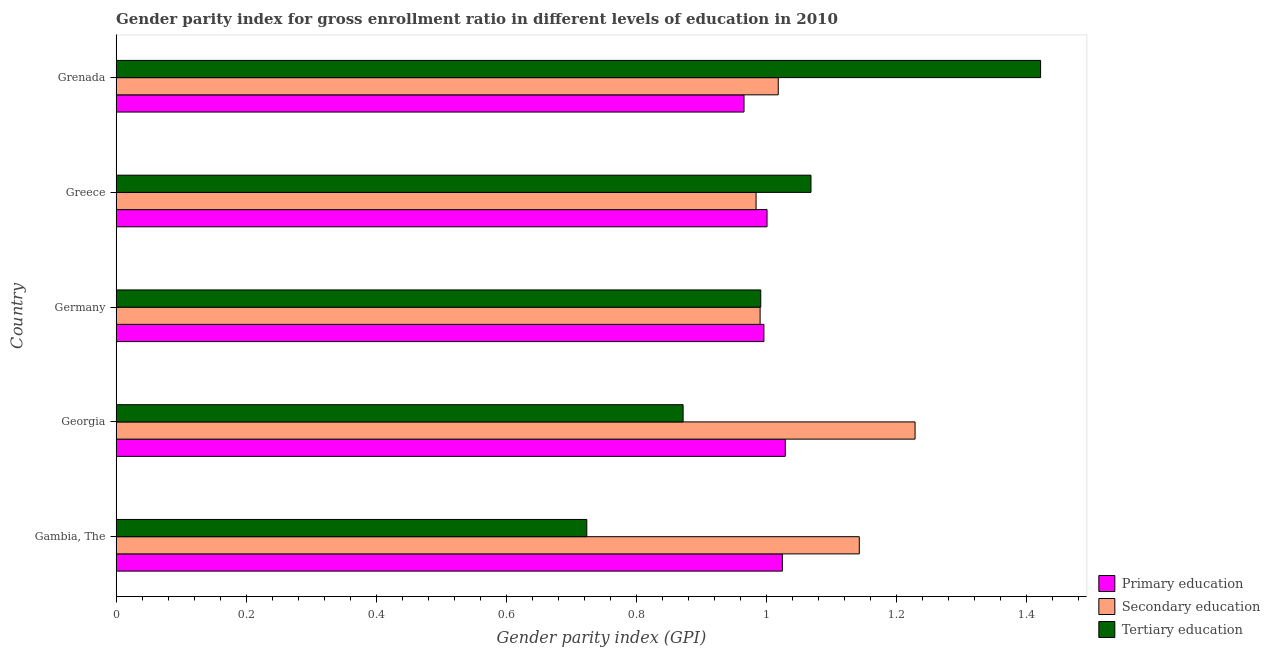How many groups of bars are there?
Offer a very short reply. 5. Are the number of bars per tick equal to the number of legend labels?
Ensure brevity in your answer.  Yes. Are the number of bars on each tick of the Y-axis equal?
Provide a succinct answer. Yes. How many bars are there on the 1st tick from the bottom?
Provide a short and direct response. 3. What is the label of the 4th group of bars from the top?
Ensure brevity in your answer.  Georgia. In how many cases, is the number of bars for a given country not equal to the number of legend labels?
Your answer should be very brief. 0. What is the gender parity index in secondary education in Germany?
Provide a short and direct response. 0.99. Across all countries, what is the maximum gender parity index in tertiary education?
Your response must be concise. 1.42. Across all countries, what is the minimum gender parity index in tertiary education?
Ensure brevity in your answer.  0.72. In which country was the gender parity index in tertiary education maximum?
Your answer should be very brief. Grenada. In which country was the gender parity index in tertiary education minimum?
Your response must be concise. Gambia, The. What is the total gender parity index in tertiary education in the graph?
Your answer should be compact. 5.08. What is the difference between the gender parity index in tertiary education in Georgia and that in Greece?
Your answer should be compact. -0.2. What is the difference between the gender parity index in tertiary education in Grenada and the gender parity index in secondary education in Greece?
Offer a terse response. 0.44. What is the average gender parity index in secondary education per country?
Offer a very short reply. 1.07. What is the difference between the gender parity index in secondary education and gender parity index in tertiary education in Georgia?
Provide a short and direct response. 0.36. In how many countries, is the gender parity index in primary education greater than 0.04 ?
Your response must be concise. 5. What is the ratio of the gender parity index in secondary education in Germany to that in Grenada?
Ensure brevity in your answer.  0.97. Is the gender parity index in primary education in Georgia less than that in Germany?
Give a very brief answer. No. Is the difference between the gender parity index in secondary education in Georgia and Greece greater than the difference between the gender parity index in tertiary education in Georgia and Greece?
Give a very brief answer. Yes. What is the difference between the highest and the second highest gender parity index in primary education?
Your answer should be compact. 0. What is the difference between the highest and the lowest gender parity index in tertiary education?
Keep it short and to the point. 0.7. In how many countries, is the gender parity index in tertiary education greater than the average gender parity index in tertiary education taken over all countries?
Your response must be concise. 2. Is the sum of the gender parity index in tertiary education in Georgia and Germany greater than the maximum gender parity index in secondary education across all countries?
Give a very brief answer. Yes. What does the 2nd bar from the top in Grenada represents?
Provide a succinct answer. Secondary education. What does the 3rd bar from the bottom in Germany represents?
Give a very brief answer. Tertiary education. Is it the case that in every country, the sum of the gender parity index in primary education and gender parity index in secondary education is greater than the gender parity index in tertiary education?
Your answer should be very brief. Yes. How many bars are there?
Give a very brief answer. 15. How many countries are there in the graph?
Your response must be concise. 5. Does the graph contain any zero values?
Ensure brevity in your answer.  No. How many legend labels are there?
Make the answer very short. 3. How are the legend labels stacked?
Make the answer very short. Vertical. What is the title of the graph?
Your response must be concise. Gender parity index for gross enrollment ratio in different levels of education in 2010. Does "Tertiary education" appear as one of the legend labels in the graph?
Your answer should be compact. Yes. What is the label or title of the X-axis?
Provide a short and direct response. Gender parity index (GPI). What is the label or title of the Y-axis?
Provide a succinct answer. Country. What is the Gender parity index (GPI) in Primary education in Gambia, The?
Provide a succinct answer. 1.02. What is the Gender parity index (GPI) of Secondary education in Gambia, The?
Offer a very short reply. 1.14. What is the Gender parity index (GPI) in Tertiary education in Gambia, The?
Make the answer very short. 0.72. What is the Gender parity index (GPI) in Primary education in Georgia?
Ensure brevity in your answer.  1.03. What is the Gender parity index (GPI) in Secondary education in Georgia?
Make the answer very short. 1.23. What is the Gender parity index (GPI) of Tertiary education in Georgia?
Your answer should be very brief. 0.87. What is the Gender parity index (GPI) of Primary education in Germany?
Offer a very short reply. 1. What is the Gender parity index (GPI) in Secondary education in Germany?
Your answer should be very brief. 0.99. What is the Gender parity index (GPI) in Tertiary education in Germany?
Give a very brief answer. 0.99. What is the Gender parity index (GPI) in Primary education in Greece?
Give a very brief answer. 1. What is the Gender parity index (GPI) in Secondary education in Greece?
Provide a short and direct response. 0.98. What is the Gender parity index (GPI) in Tertiary education in Greece?
Give a very brief answer. 1.07. What is the Gender parity index (GPI) in Primary education in Grenada?
Give a very brief answer. 0.97. What is the Gender parity index (GPI) in Secondary education in Grenada?
Keep it short and to the point. 1.02. What is the Gender parity index (GPI) of Tertiary education in Grenada?
Offer a terse response. 1.42. Across all countries, what is the maximum Gender parity index (GPI) in Primary education?
Your answer should be compact. 1.03. Across all countries, what is the maximum Gender parity index (GPI) in Secondary education?
Offer a terse response. 1.23. Across all countries, what is the maximum Gender parity index (GPI) of Tertiary education?
Ensure brevity in your answer.  1.42. Across all countries, what is the minimum Gender parity index (GPI) of Primary education?
Offer a terse response. 0.97. Across all countries, what is the minimum Gender parity index (GPI) of Secondary education?
Make the answer very short. 0.98. Across all countries, what is the minimum Gender parity index (GPI) in Tertiary education?
Offer a very short reply. 0.72. What is the total Gender parity index (GPI) of Primary education in the graph?
Your answer should be compact. 5.02. What is the total Gender parity index (GPI) of Secondary education in the graph?
Keep it short and to the point. 5.37. What is the total Gender parity index (GPI) of Tertiary education in the graph?
Offer a very short reply. 5.08. What is the difference between the Gender parity index (GPI) of Primary education in Gambia, The and that in Georgia?
Offer a terse response. -0. What is the difference between the Gender parity index (GPI) in Secondary education in Gambia, The and that in Georgia?
Offer a terse response. -0.09. What is the difference between the Gender parity index (GPI) of Tertiary education in Gambia, The and that in Georgia?
Provide a short and direct response. -0.15. What is the difference between the Gender parity index (GPI) in Primary education in Gambia, The and that in Germany?
Your answer should be very brief. 0.03. What is the difference between the Gender parity index (GPI) in Secondary education in Gambia, The and that in Germany?
Your response must be concise. 0.15. What is the difference between the Gender parity index (GPI) in Tertiary education in Gambia, The and that in Germany?
Give a very brief answer. -0.27. What is the difference between the Gender parity index (GPI) of Primary education in Gambia, The and that in Greece?
Provide a succinct answer. 0.02. What is the difference between the Gender parity index (GPI) of Secondary education in Gambia, The and that in Greece?
Offer a very short reply. 0.16. What is the difference between the Gender parity index (GPI) of Tertiary education in Gambia, The and that in Greece?
Your response must be concise. -0.34. What is the difference between the Gender parity index (GPI) in Primary education in Gambia, The and that in Grenada?
Make the answer very short. 0.06. What is the difference between the Gender parity index (GPI) in Secondary education in Gambia, The and that in Grenada?
Your response must be concise. 0.12. What is the difference between the Gender parity index (GPI) in Tertiary education in Gambia, The and that in Grenada?
Your response must be concise. -0.7. What is the difference between the Gender parity index (GPI) of Primary education in Georgia and that in Germany?
Your answer should be compact. 0.03. What is the difference between the Gender parity index (GPI) in Secondary education in Georgia and that in Germany?
Keep it short and to the point. 0.24. What is the difference between the Gender parity index (GPI) in Tertiary education in Georgia and that in Germany?
Provide a succinct answer. -0.12. What is the difference between the Gender parity index (GPI) in Primary education in Georgia and that in Greece?
Keep it short and to the point. 0.03. What is the difference between the Gender parity index (GPI) in Secondary education in Georgia and that in Greece?
Ensure brevity in your answer.  0.24. What is the difference between the Gender parity index (GPI) of Tertiary education in Georgia and that in Greece?
Make the answer very short. -0.2. What is the difference between the Gender parity index (GPI) in Primary education in Georgia and that in Grenada?
Make the answer very short. 0.06. What is the difference between the Gender parity index (GPI) in Secondary education in Georgia and that in Grenada?
Your answer should be compact. 0.21. What is the difference between the Gender parity index (GPI) in Tertiary education in Georgia and that in Grenada?
Offer a very short reply. -0.55. What is the difference between the Gender parity index (GPI) in Primary education in Germany and that in Greece?
Offer a very short reply. -0. What is the difference between the Gender parity index (GPI) in Secondary education in Germany and that in Greece?
Provide a succinct answer. 0.01. What is the difference between the Gender parity index (GPI) of Tertiary education in Germany and that in Greece?
Your answer should be compact. -0.08. What is the difference between the Gender parity index (GPI) of Primary education in Germany and that in Grenada?
Ensure brevity in your answer.  0.03. What is the difference between the Gender parity index (GPI) of Secondary education in Germany and that in Grenada?
Provide a short and direct response. -0.03. What is the difference between the Gender parity index (GPI) in Tertiary education in Germany and that in Grenada?
Your answer should be very brief. -0.43. What is the difference between the Gender parity index (GPI) in Primary education in Greece and that in Grenada?
Give a very brief answer. 0.04. What is the difference between the Gender parity index (GPI) of Secondary education in Greece and that in Grenada?
Offer a terse response. -0.03. What is the difference between the Gender parity index (GPI) in Tertiary education in Greece and that in Grenada?
Offer a terse response. -0.35. What is the difference between the Gender parity index (GPI) of Primary education in Gambia, The and the Gender parity index (GPI) of Secondary education in Georgia?
Provide a succinct answer. -0.2. What is the difference between the Gender parity index (GPI) of Primary education in Gambia, The and the Gender parity index (GPI) of Tertiary education in Georgia?
Provide a succinct answer. 0.15. What is the difference between the Gender parity index (GPI) in Secondary education in Gambia, The and the Gender parity index (GPI) in Tertiary education in Georgia?
Your answer should be compact. 0.27. What is the difference between the Gender parity index (GPI) in Primary education in Gambia, The and the Gender parity index (GPI) in Secondary education in Germany?
Keep it short and to the point. 0.03. What is the difference between the Gender parity index (GPI) in Primary education in Gambia, The and the Gender parity index (GPI) in Tertiary education in Germany?
Keep it short and to the point. 0.03. What is the difference between the Gender parity index (GPI) of Secondary education in Gambia, The and the Gender parity index (GPI) of Tertiary education in Germany?
Offer a very short reply. 0.15. What is the difference between the Gender parity index (GPI) in Primary education in Gambia, The and the Gender parity index (GPI) in Secondary education in Greece?
Make the answer very short. 0.04. What is the difference between the Gender parity index (GPI) of Primary education in Gambia, The and the Gender parity index (GPI) of Tertiary education in Greece?
Provide a short and direct response. -0.04. What is the difference between the Gender parity index (GPI) of Secondary education in Gambia, The and the Gender parity index (GPI) of Tertiary education in Greece?
Provide a succinct answer. 0.07. What is the difference between the Gender parity index (GPI) in Primary education in Gambia, The and the Gender parity index (GPI) in Secondary education in Grenada?
Your answer should be very brief. 0.01. What is the difference between the Gender parity index (GPI) of Primary education in Gambia, The and the Gender parity index (GPI) of Tertiary education in Grenada?
Your answer should be very brief. -0.4. What is the difference between the Gender parity index (GPI) in Secondary education in Gambia, The and the Gender parity index (GPI) in Tertiary education in Grenada?
Offer a very short reply. -0.28. What is the difference between the Gender parity index (GPI) in Primary education in Georgia and the Gender parity index (GPI) in Secondary education in Germany?
Offer a terse response. 0.04. What is the difference between the Gender parity index (GPI) in Primary education in Georgia and the Gender parity index (GPI) in Tertiary education in Germany?
Provide a short and direct response. 0.04. What is the difference between the Gender parity index (GPI) in Secondary education in Georgia and the Gender parity index (GPI) in Tertiary education in Germany?
Provide a succinct answer. 0.24. What is the difference between the Gender parity index (GPI) of Primary education in Georgia and the Gender parity index (GPI) of Secondary education in Greece?
Give a very brief answer. 0.04. What is the difference between the Gender parity index (GPI) of Primary education in Georgia and the Gender parity index (GPI) of Tertiary education in Greece?
Provide a short and direct response. -0.04. What is the difference between the Gender parity index (GPI) in Secondary education in Georgia and the Gender parity index (GPI) in Tertiary education in Greece?
Offer a very short reply. 0.16. What is the difference between the Gender parity index (GPI) in Primary education in Georgia and the Gender parity index (GPI) in Secondary education in Grenada?
Give a very brief answer. 0.01. What is the difference between the Gender parity index (GPI) in Primary education in Georgia and the Gender parity index (GPI) in Tertiary education in Grenada?
Keep it short and to the point. -0.39. What is the difference between the Gender parity index (GPI) in Secondary education in Georgia and the Gender parity index (GPI) in Tertiary education in Grenada?
Your response must be concise. -0.19. What is the difference between the Gender parity index (GPI) of Primary education in Germany and the Gender parity index (GPI) of Secondary education in Greece?
Provide a short and direct response. 0.01. What is the difference between the Gender parity index (GPI) in Primary education in Germany and the Gender parity index (GPI) in Tertiary education in Greece?
Offer a very short reply. -0.07. What is the difference between the Gender parity index (GPI) in Secondary education in Germany and the Gender parity index (GPI) in Tertiary education in Greece?
Make the answer very short. -0.08. What is the difference between the Gender parity index (GPI) of Primary education in Germany and the Gender parity index (GPI) of Secondary education in Grenada?
Provide a short and direct response. -0.02. What is the difference between the Gender parity index (GPI) of Primary education in Germany and the Gender parity index (GPI) of Tertiary education in Grenada?
Your answer should be compact. -0.43. What is the difference between the Gender parity index (GPI) in Secondary education in Germany and the Gender parity index (GPI) in Tertiary education in Grenada?
Provide a succinct answer. -0.43. What is the difference between the Gender parity index (GPI) of Primary education in Greece and the Gender parity index (GPI) of Secondary education in Grenada?
Ensure brevity in your answer.  -0.02. What is the difference between the Gender parity index (GPI) in Primary education in Greece and the Gender parity index (GPI) in Tertiary education in Grenada?
Keep it short and to the point. -0.42. What is the difference between the Gender parity index (GPI) in Secondary education in Greece and the Gender parity index (GPI) in Tertiary education in Grenada?
Ensure brevity in your answer.  -0.44. What is the average Gender parity index (GPI) of Secondary education per country?
Your response must be concise. 1.07. What is the average Gender parity index (GPI) of Tertiary education per country?
Your response must be concise. 1.02. What is the difference between the Gender parity index (GPI) in Primary education and Gender parity index (GPI) in Secondary education in Gambia, The?
Provide a short and direct response. -0.12. What is the difference between the Gender parity index (GPI) of Primary education and Gender parity index (GPI) of Tertiary education in Gambia, The?
Provide a succinct answer. 0.3. What is the difference between the Gender parity index (GPI) in Secondary education and Gender parity index (GPI) in Tertiary education in Gambia, The?
Keep it short and to the point. 0.42. What is the difference between the Gender parity index (GPI) of Primary education and Gender parity index (GPI) of Secondary education in Georgia?
Ensure brevity in your answer.  -0.2. What is the difference between the Gender parity index (GPI) of Primary education and Gender parity index (GPI) of Tertiary education in Georgia?
Your response must be concise. 0.16. What is the difference between the Gender parity index (GPI) in Secondary education and Gender parity index (GPI) in Tertiary education in Georgia?
Provide a succinct answer. 0.36. What is the difference between the Gender parity index (GPI) in Primary education and Gender parity index (GPI) in Secondary education in Germany?
Provide a succinct answer. 0.01. What is the difference between the Gender parity index (GPI) of Primary education and Gender parity index (GPI) of Tertiary education in Germany?
Provide a short and direct response. 0. What is the difference between the Gender parity index (GPI) in Secondary education and Gender parity index (GPI) in Tertiary education in Germany?
Make the answer very short. -0. What is the difference between the Gender parity index (GPI) in Primary education and Gender parity index (GPI) in Secondary education in Greece?
Your answer should be very brief. 0.02. What is the difference between the Gender parity index (GPI) in Primary education and Gender parity index (GPI) in Tertiary education in Greece?
Provide a short and direct response. -0.07. What is the difference between the Gender parity index (GPI) in Secondary education and Gender parity index (GPI) in Tertiary education in Greece?
Provide a short and direct response. -0.08. What is the difference between the Gender parity index (GPI) in Primary education and Gender parity index (GPI) in Secondary education in Grenada?
Your answer should be compact. -0.05. What is the difference between the Gender parity index (GPI) of Primary education and Gender parity index (GPI) of Tertiary education in Grenada?
Provide a short and direct response. -0.46. What is the difference between the Gender parity index (GPI) in Secondary education and Gender parity index (GPI) in Tertiary education in Grenada?
Keep it short and to the point. -0.4. What is the ratio of the Gender parity index (GPI) of Primary education in Gambia, The to that in Georgia?
Ensure brevity in your answer.  1. What is the ratio of the Gender parity index (GPI) in Secondary education in Gambia, The to that in Georgia?
Offer a terse response. 0.93. What is the ratio of the Gender parity index (GPI) in Tertiary education in Gambia, The to that in Georgia?
Your answer should be compact. 0.83. What is the ratio of the Gender parity index (GPI) in Primary education in Gambia, The to that in Germany?
Keep it short and to the point. 1.03. What is the ratio of the Gender parity index (GPI) of Secondary education in Gambia, The to that in Germany?
Provide a succinct answer. 1.15. What is the ratio of the Gender parity index (GPI) in Tertiary education in Gambia, The to that in Germany?
Ensure brevity in your answer.  0.73. What is the ratio of the Gender parity index (GPI) of Primary education in Gambia, The to that in Greece?
Your answer should be very brief. 1.02. What is the ratio of the Gender parity index (GPI) in Secondary education in Gambia, The to that in Greece?
Your answer should be compact. 1.16. What is the ratio of the Gender parity index (GPI) of Tertiary education in Gambia, The to that in Greece?
Keep it short and to the point. 0.68. What is the ratio of the Gender parity index (GPI) of Primary education in Gambia, The to that in Grenada?
Give a very brief answer. 1.06. What is the ratio of the Gender parity index (GPI) of Secondary education in Gambia, The to that in Grenada?
Ensure brevity in your answer.  1.12. What is the ratio of the Gender parity index (GPI) of Tertiary education in Gambia, The to that in Grenada?
Make the answer very short. 0.51. What is the ratio of the Gender parity index (GPI) of Primary education in Georgia to that in Germany?
Provide a short and direct response. 1.03. What is the ratio of the Gender parity index (GPI) of Secondary education in Georgia to that in Germany?
Ensure brevity in your answer.  1.24. What is the ratio of the Gender parity index (GPI) in Tertiary education in Georgia to that in Germany?
Make the answer very short. 0.88. What is the ratio of the Gender parity index (GPI) in Primary education in Georgia to that in Greece?
Your answer should be very brief. 1.03. What is the ratio of the Gender parity index (GPI) in Secondary education in Georgia to that in Greece?
Ensure brevity in your answer.  1.25. What is the ratio of the Gender parity index (GPI) of Tertiary education in Georgia to that in Greece?
Provide a short and direct response. 0.82. What is the ratio of the Gender parity index (GPI) in Primary education in Georgia to that in Grenada?
Offer a terse response. 1.07. What is the ratio of the Gender parity index (GPI) in Secondary education in Georgia to that in Grenada?
Give a very brief answer. 1.21. What is the ratio of the Gender parity index (GPI) in Tertiary education in Georgia to that in Grenada?
Your response must be concise. 0.61. What is the ratio of the Gender parity index (GPI) of Primary education in Germany to that in Greece?
Provide a short and direct response. 1. What is the ratio of the Gender parity index (GPI) in Secondary education in Germany to that in Greece?
Your answer should be compact. 1.01. What is the ratio of the Gender parity index (GPI) in Tertiary education in Germany to that in Greece?
Provide a succinct answer. 0.93. What is the ratio of the Gender parity index (GPI) of Primary education in Germany to that in Grenada?
Offer a terse response. 1.03. What is the ratio of the Gender parity index (GPI) in Secondary education in Germany to that in Grenada?
Offer a terse response. 0.97. What is the ratio of the Gender parity index (GPI) in Tertiary education in Germany to that in Grenada?
Your answer should be compact. 0.7. What is the ratio of the Gender parity index (GPI) in Primary education in Greece to that in Grenada?
Provide a succinct answer. 1.04. What is the ratio of the Gender parity index (GPI) of Secondary education in Greece to that in Grenada?
Keep it short and to the point. 0.97. What is the ratio of the Gender parity index (GPI) in Tertiary education in Greece to that in Grenada?
Make the answer very short. 0.75. What is the difference between the highest and the second highest Gender parity index (GPI) in Primary education?
Ensure brevity in your answer.  0. What is the difference between the highest and the second highest Gender parity index (GPI) in Secondary education?
Provide a succinct answer. 0.09. What is the difference between the highest and the second highest Gender parity index (GPI) of Tertiary education?
Your response must be concise. 0.35. What is the difference between the highest and the lowest Gender parity index (GPI) of Primary education?
Offer a very short reply. 0.06. What is the difference between the highest and the lowest Gender parity index (GPI) in Secondary education?
Provide a succinct answer. 0.24. What is the difference between the highest and the lowest Gender parity index (GPI) of Tertiary education?
Provide a short and direct response. 0.7. 